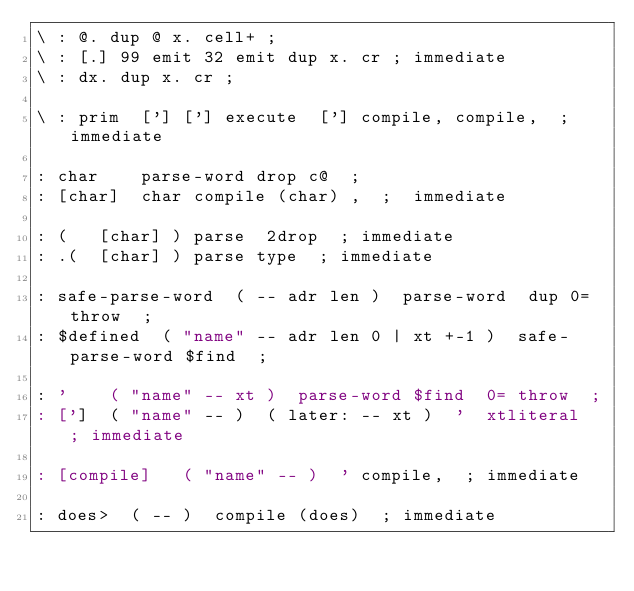Convert code to text. <code><loc_0><loc_0><loc_500><loc_500><_Forth_>\ : @. dup @ x. cell+ ;
\ : [.] 99 emit 32 emit dup x. cr ; immediate
\ : dx. dup x. cr ;

\ : prim  ['] ['] execute  ['] compile, compile,  ; immediate

: char    parse-word drop c@  ;
: [char]  char compile (char) ,  ;  immediate

: (   [char] ) parse  2drop  ; immediate
: .(  [char] ) parse type  ; immediate

: safe-parse-word  ( -- adr len )  parse-word  dup 0= throw  ;
: $defined  ( "name" -- adr len 0 | xt +-1 )  safe-parse-word $find  ;

: '    ( "name" -- xt )  parse-word $find  0= throw  ;
: [']  ( "name" -- )  ( later: -- xt )  '  xtliteral  ; immediate

: [compile]   ( "name" -- )  ' compile,  ; immediate

: does>  ( -- )  compile (does)  ; immediate
</code> 